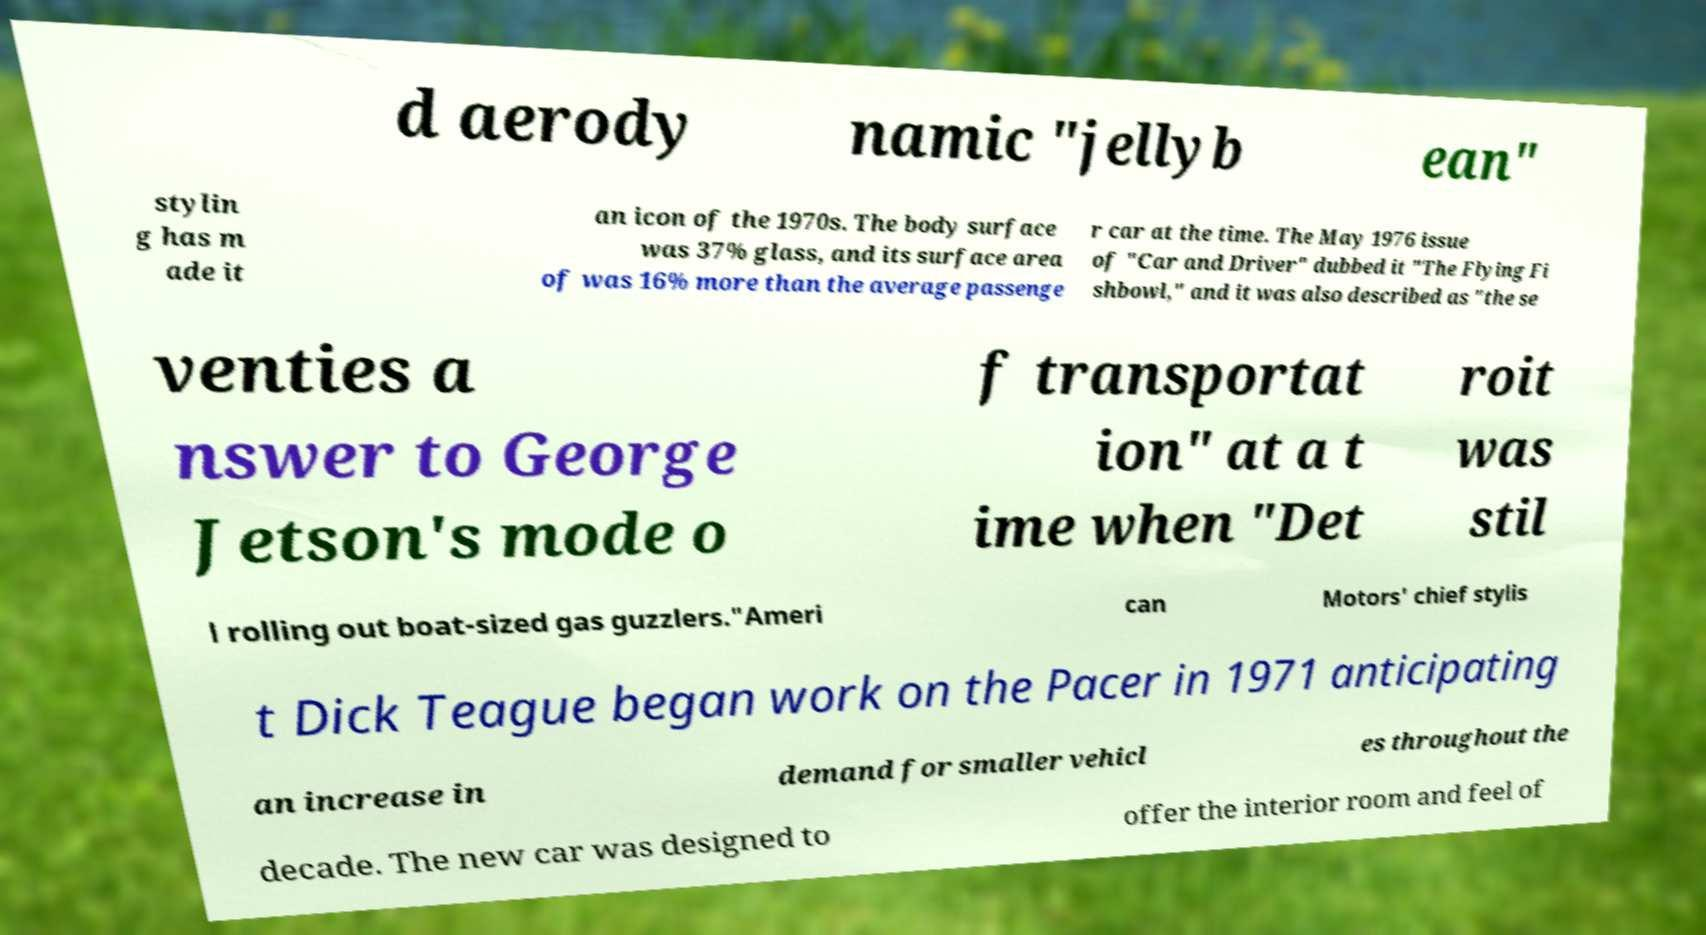Please read and relay the text visible in this image. What does it say? d aerody namic "jellyb ean" stylin g has m ade it an icon of the 1970s. The body surface was 37% glass, and its surface area of was 16% more than the average passenge r car at the time. The May 1976 issue of "Car and Driver" dubbed it "The Flying Fi shbowl," and it was also described as "the se venties a nswer to George Jetson's mode o f transportat ion" at a t ime when "Det roit was stil l rolling out boat-sized gas guzzlers."Ameri can Motors' chief stylis t Dick Teague began work on the Pacer in 1971 anticipating an increase in demand for smaller vehicl es throughout the decade. The new car was designed to offer the interior room and feel of 